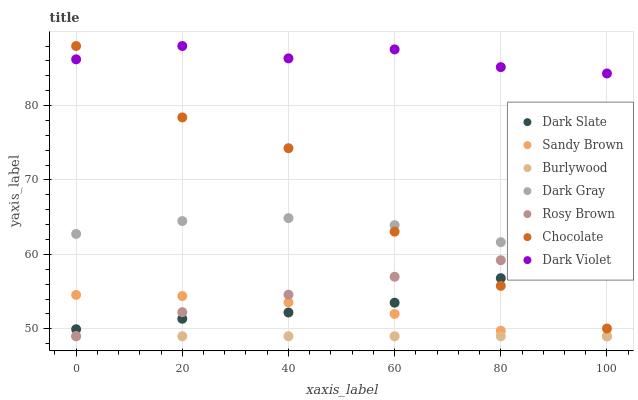Does Burlywood have the minimum area under the curve?
Answer yes or no. Yes. Does Dark Violet have the maximum area under the curve?
Answer yes or no. Yes. Does Rosy Brown have the minimum area under the curve?
Answer yes or no. No. Does Rosy Brown have the maximum area under the curve?
Answer yes or no. No. Is Burlywood the smoothest?
Answer yes or no. Yes. Is Chocolate the roughest?
Answer yes or no. Yes. Is Rosy Brown the smoothest?
Answer yes or no. No. Is Rosy Brown the roughest?
Answer yes or no. No. Does Burlywood have the lowest value?
Answer yes or no. Yes. Does Dark Violet have the lowest value?
Answer yes or no. No. Does Chocolate have the highest value?
Answer yes or no. Yes. Does Rosy Brown have the highest value?
Answer yes or no. No. Is Sandy Brown less than Dark Gray?
Answer yes or no. Yes. Is Dark Violet greater than Sandy Brown?
Answer yes or no. Yes. Does Chocolate intersect Rosy Brown?
Answer yes or no. Yes. Is Chocolate less than Rosy Brown?
Answer yes or no. No. Is Chocolate greater than Rosy Brown?
Answer yes or no. No. Does Sandy Brown intersect Dark Gray?
Answer yes or no. No. 